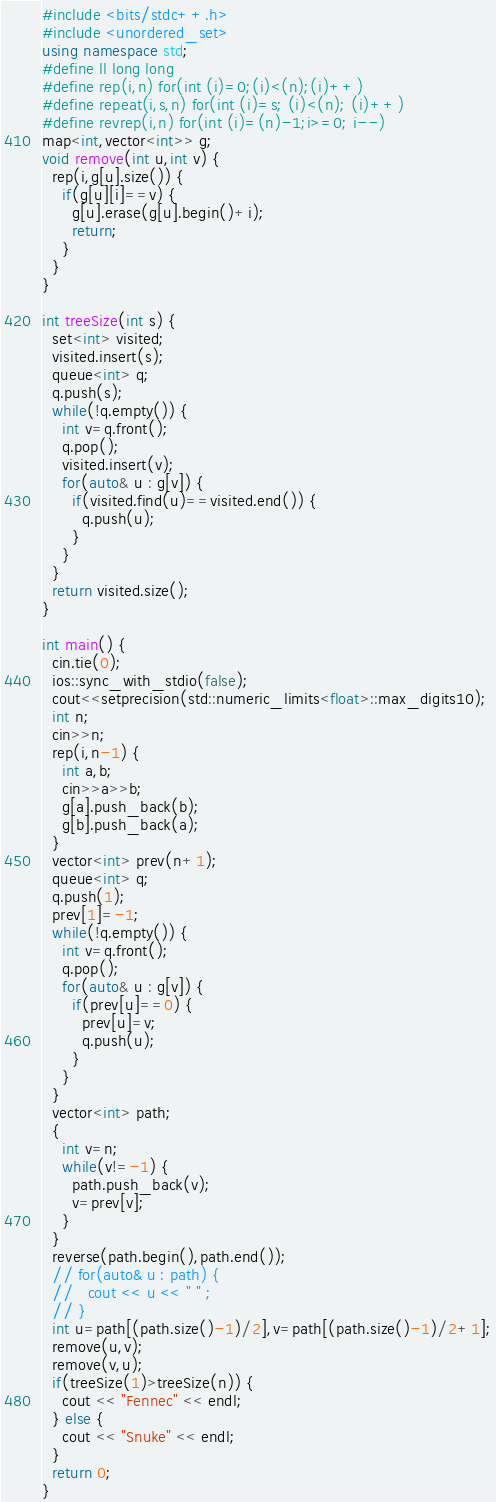Convert code to text. <code><loc_0><loc_0><loc_500><loc_500><_C++_>#include <bits/stdc++.h>
#include <unordered_set>
using namespace std;
#define ll long long
#define rep(i,n) for(int (i)=0;(i)<(n);(i)++)
#define repeat(i,s,n) for(int (i)=s; (i)<(n); (i)++)
#define revrep(i,n) for(int (i)=(n)-1;i>=0; i--)
map<int,vector<int>> g;
void remove(int u,int v) {
  rep(i,g[u].size()) {
    if(g[u][i]==v) {
      g[u].erase(g[u].begin()+i);
      return;
    }
  }
}

int treeSize(int s) {
  set<int> visited;
  visited.insert(s);
  queue<int> q;
  q.push(s);
  while(!q.empty()) {
    int v=q.front();
    q.pop();
    visited.insert(v);
    for(auto& u : g[v]) {
      if(visited.find(u)==visited.end()) {
        q.push(u);
      }
    }
  }
  return visited.size();
}

int main() {
  cin.tie(0);
  ios::sync_with_stdio(false);
  cout<<setprecision(std::numeric_limits<float>::max_digits10);
  int n;
  cin>>n;
  rep(i,n-1) {
    int a,b;
    cin>>a>>b;
    g[a].push_back(b);
    g[b].push_back(a);
  }
  vector<int> prev(n+1);
  queue<int> q;
  q.push(1);
  prev[1]=-1;
  while(!q.empty()) {
    int v=q.front();
    q.pop();
    for(auto& u : g[v]) {
      if(prev[u]==0) {
        prev[u]=v;
        q.push(u);
      }
    }
  }
  vector<int> path;
  {
    int v=n;
    while(v!=-1) {
      path.push_back(v);
      v=prev[v];
    }
  }
  reverse(path.begin(),path.end());
  // for(auto& u : path) {
  //   cout << u << " " ;
  // }
  int u=path[(path.size()-1)/2],v=path[(path.size()-1)/2+1];
  remove(u,v);
  remove(v,u);
  if(treeSize(1)>treeSize(n)) {
    cout << "Fennec" << endl;
  } else {
    cout << "Snuke" << endl;
  }
  return 0;
}
</code> 